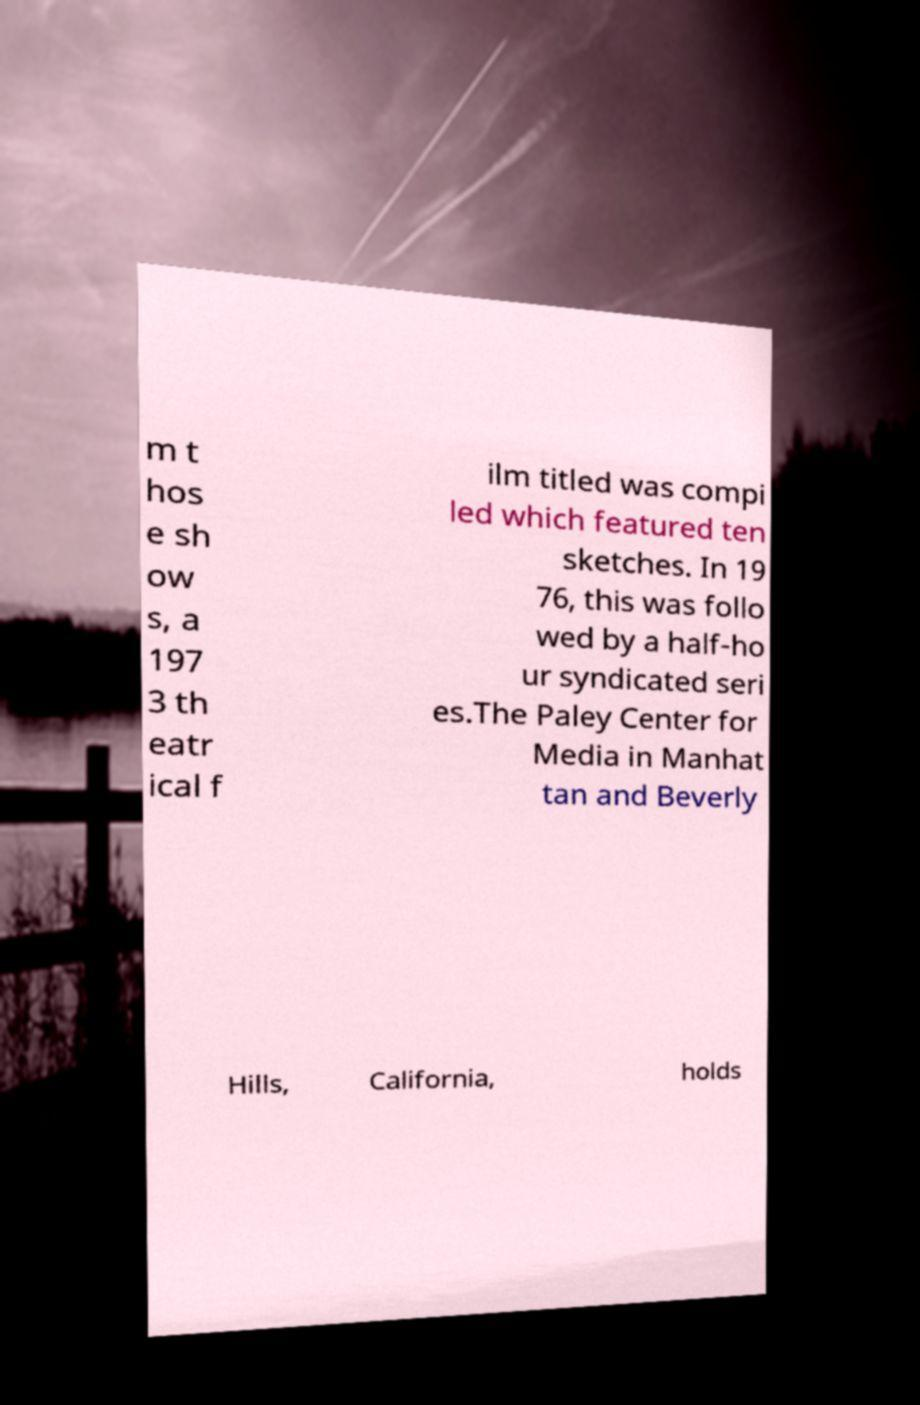Can you accurately transcribe the text from the provided image for me? m t hos e sh ow s, a 197 3 th eatr ical f ilm titled was compi led which featured ten sketches. In 19 76, this was follo wed by a half-ho ur syndicated seri es.The Paley Center for Media in Manhat tan and Beverly Hills, California, holds 